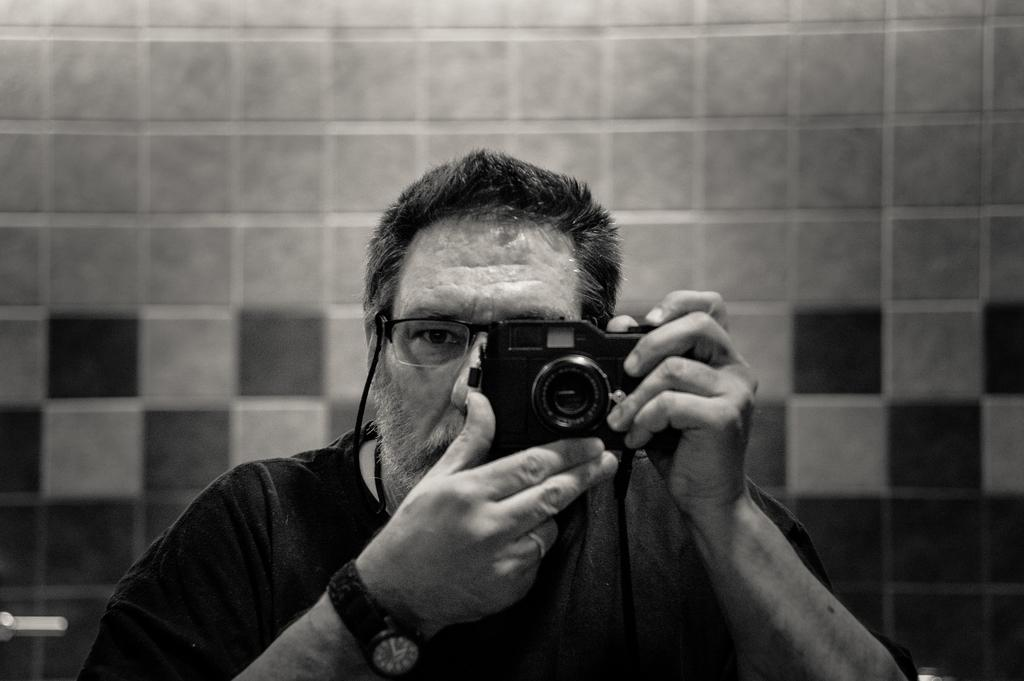What is the main subject of the image? The main subject of the image is a man. What is the man doing in the image? The man is clicking photos in the image. What tool is the man using to click photos? The man is using a camera to click photos. What type of straw is the man using to take photos in the image? There is no straw present in the image; the man is using a camera to take photos. 